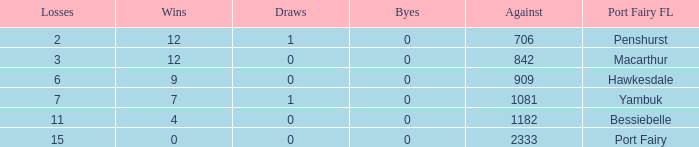How many wins for Port Fairy and against more than 2333? None. 